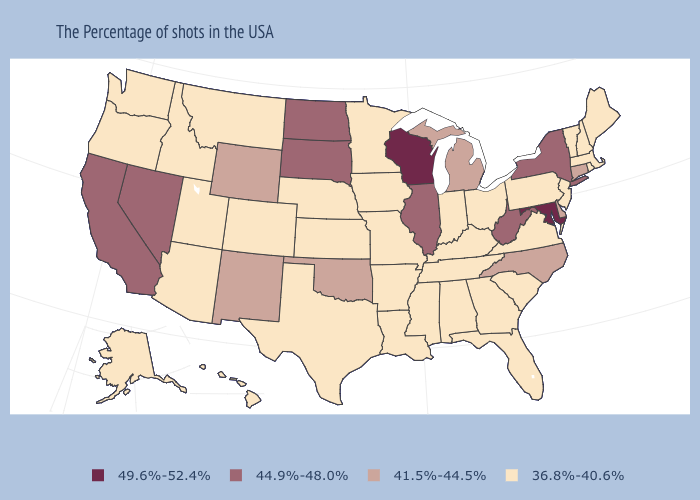Which states have the highest value in the USA?
Be succinct. Maryland, Wisconsin. What is the value of California?
Concise answer only. 44.9%-48.0%. What is the highest value in the USA?
Give a very brief answer. 49.6%-52.4%. Does New York have the highest value in the Northeast?
Quick response, please. Yes. Among the states that border Georgia , does Alabama have the lowest value?
Concise answer only. Yes. What is the value of Alabama?
Quick response, please. 36.8%-40.6%. Name the states that have a value in the range 49.6%-52.4%?
Give a very brief answer. Maryland, Wisconsin. What is the lowest value in the USA?
Answer briefly. 36.8%-40.6%. Is the legend a continuous bar?
Answer briefly. No. What is the highest value in states that border Georgia?
Keep it brief. 41.5%-44.5%. Name the states that have a value in the range 41.5%-44.5%?
Write a very short answer. Connecticut, Delaware, North Carolina, Michigan, Oklahoma, Wyoming, New Mexico. Does Illinois have a lower value than Wisconsin?
Concise answer only. Yes. 